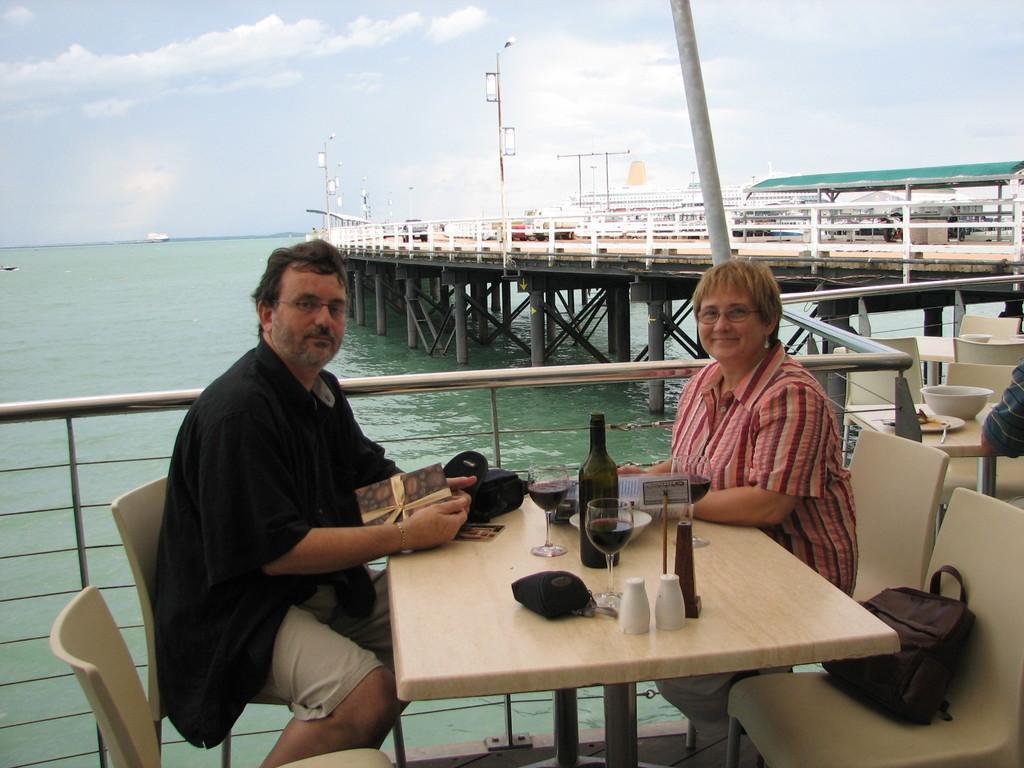Describe this image in one or two sentences. In this image there are two person sitting on the chair. On the chair there is a bag. On the table there is glass,bottle,bag and a greeting. At the back side there is a water. 